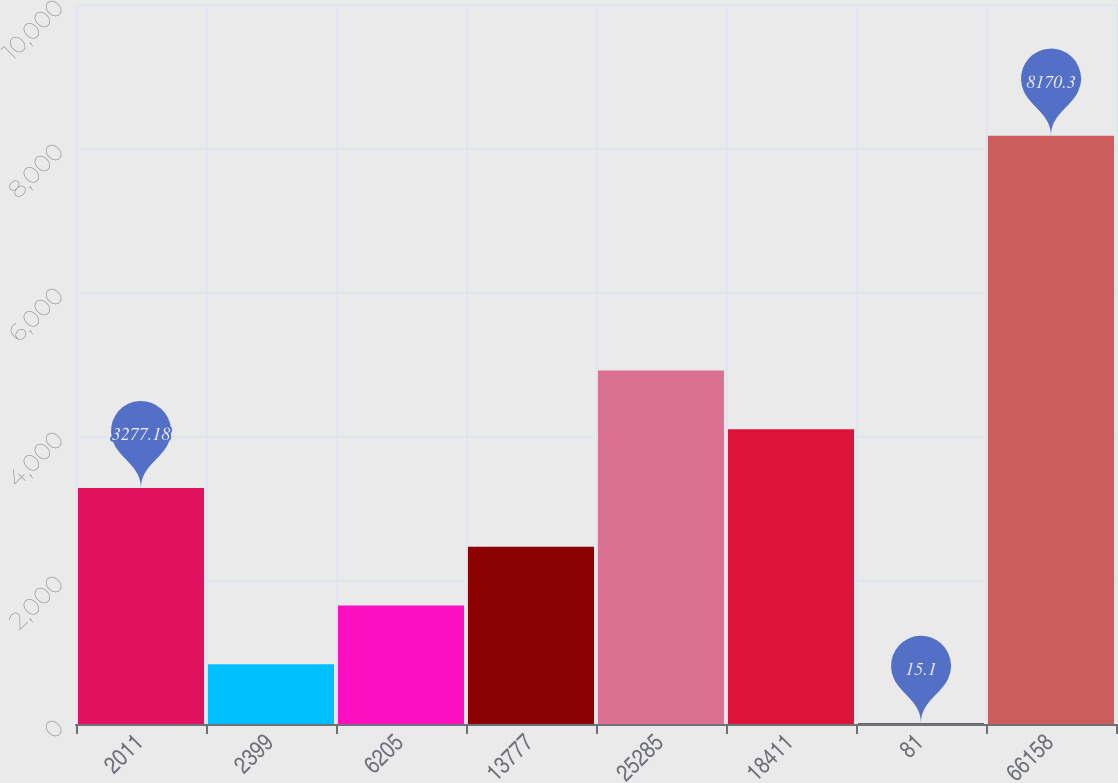<chart> <loc_0><loc_0><loc_500><loc_500><bar_chart><fcel>2011<fcel>2399<fcel>6205<fcel>13777<fcel>25285<fcel>18411<fcel>81<fcel>66158<nl><fcel>3277.18<fcel>830.62<fcel>1646.14<fcel>2461.66<fcel>4908.22<fcel>4092.7<fcel>15.1<fcel>8170.3<nl></chart> 